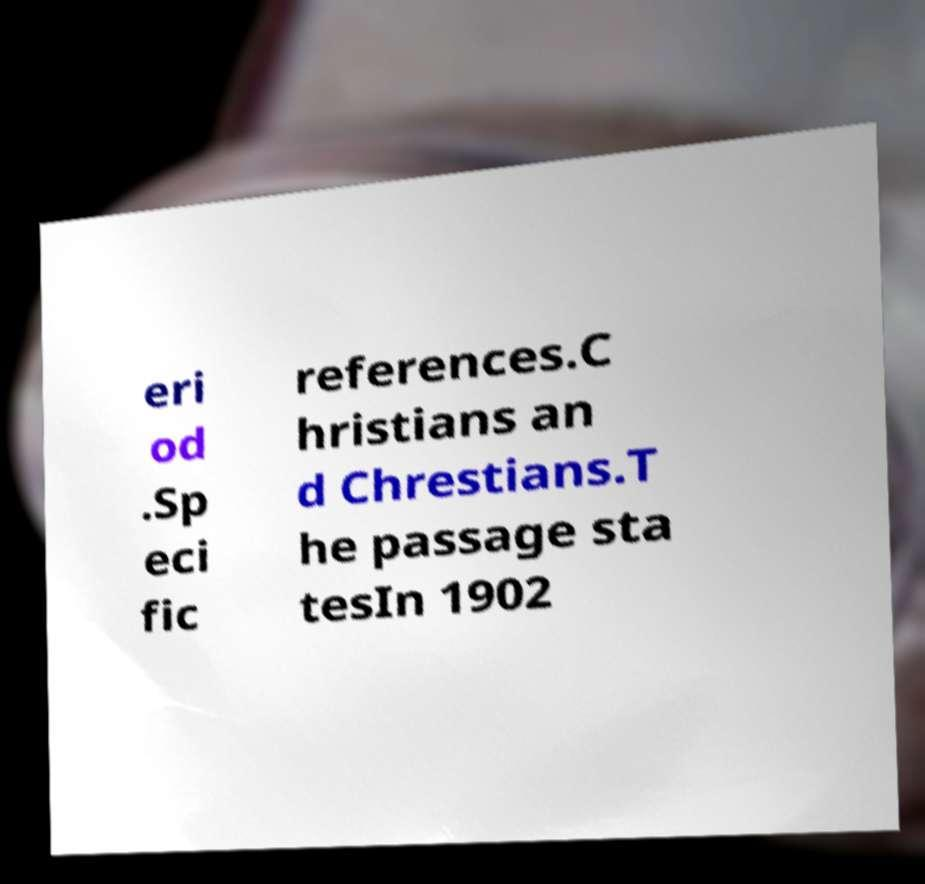Can you read and provide the text displayed in the image?This photo seems to have some interesting text. Can you extract and type it out for me? eri od .Sp eci fic references.C hristians an d Chrestians.T he passage sta tesIn 1902 